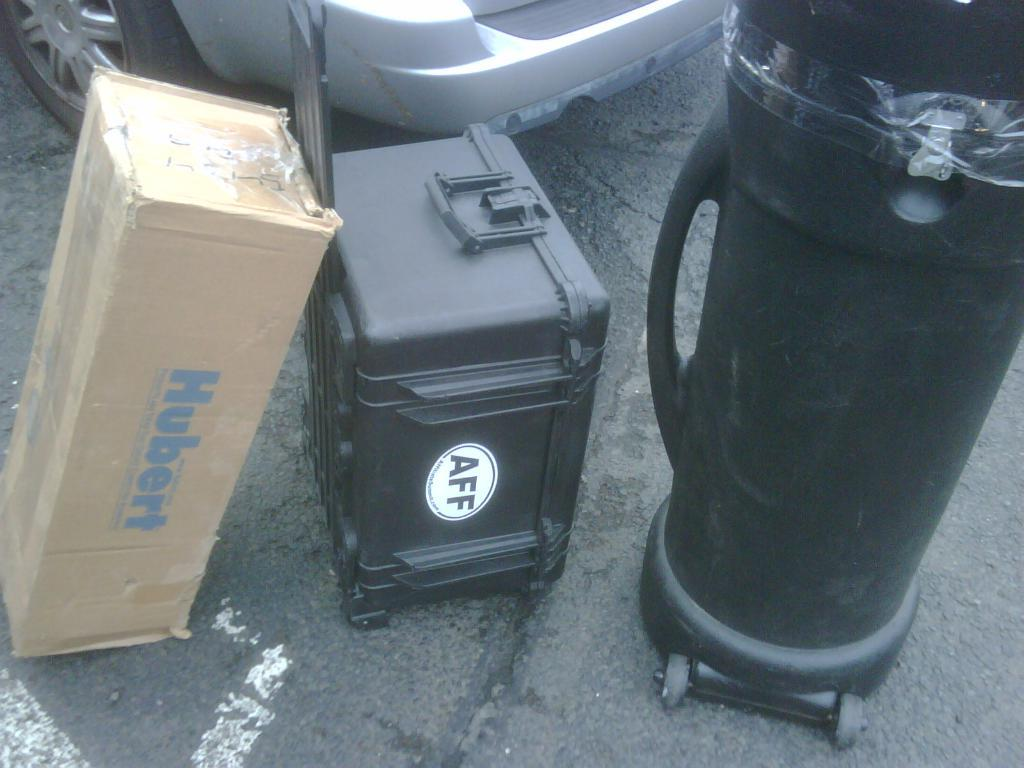<image>
Provide a brief description of the given image. A cardboard box that says Hubert next to a gear box with an AFF sticker on it. 